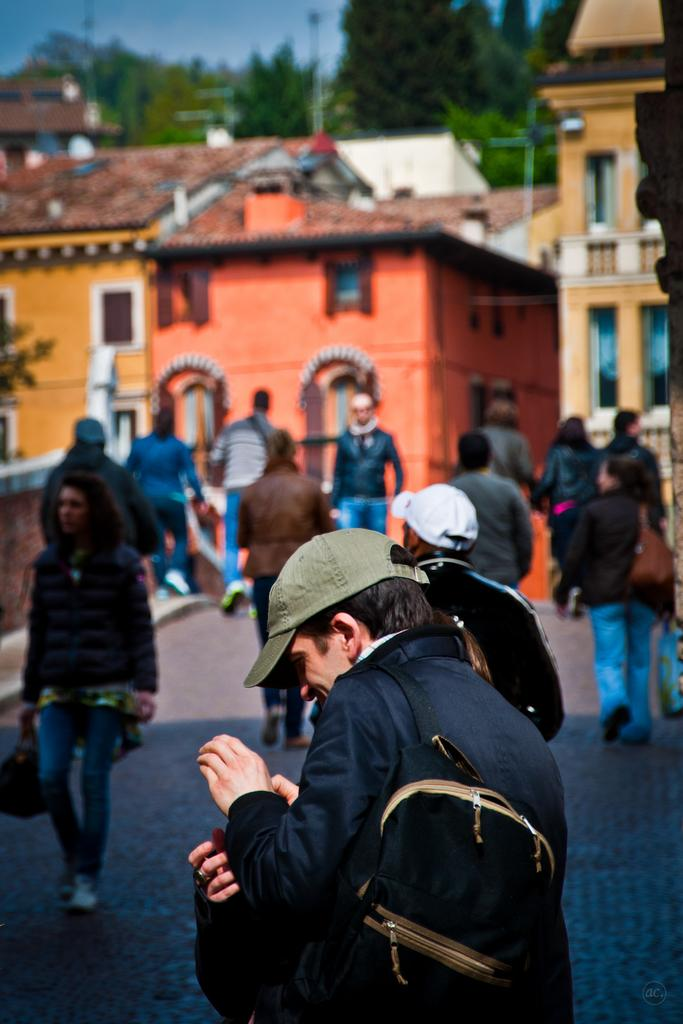What are the people in the image doing? The people in the image are walking. What structures can be seen in the image? There are buildings in the image. What type of vegetation is present in the image? There are trees in the image. What is visible in the background of the image? The sky is visible in the image. How many clocks can be seen hanging from the trees in the image? There are no clocks hanging from the trees in the image. Is there any snow visible in the image? There is no snow present in the image. 